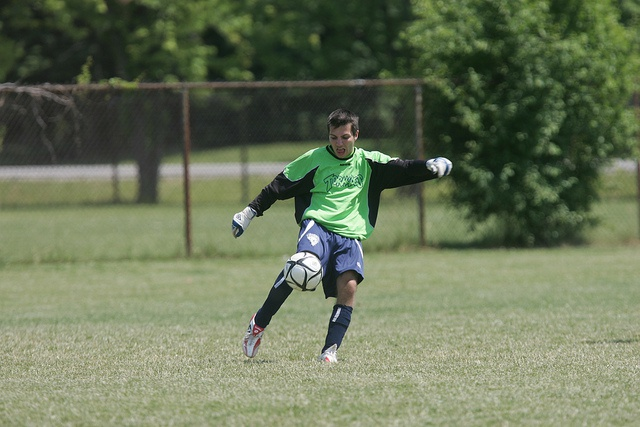Describe the objects in this image and their specific colors. I can see people in black, beige, green, and gray tones and sports ball in black, darkgray, white, and gray tones in this image. 